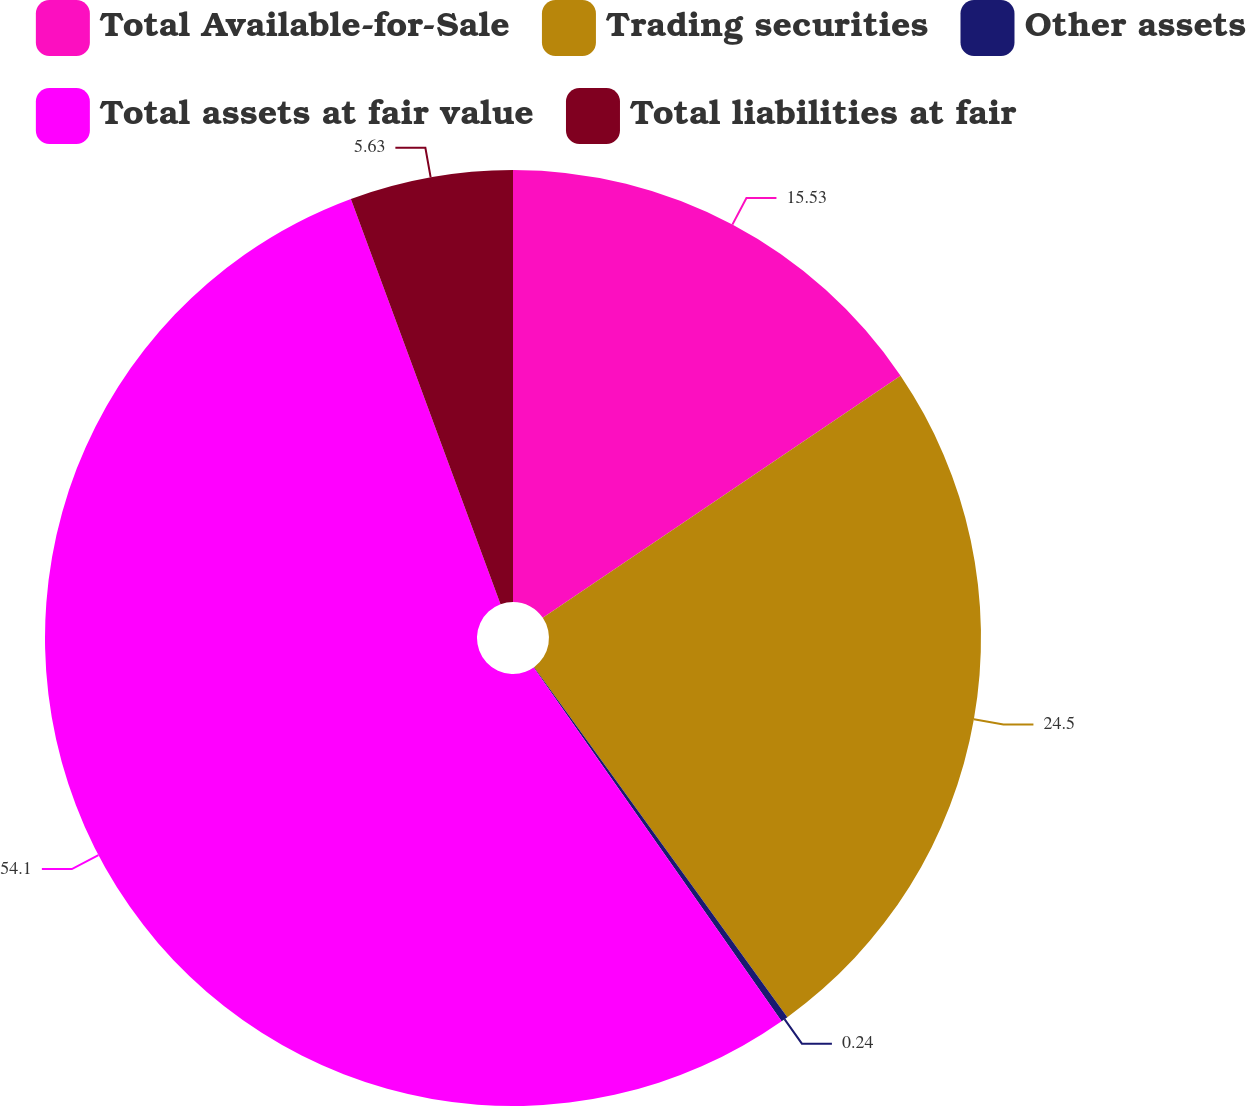Convert chart to OTSL. <chart><loc_0><loc_0><loc_500><loc_500><pie_chart><fcel>Total Available-for-Sale<fcel>Trading securities<fcel>Other assets<fcel>Total assets at fair value<fcel>Total liabilities at fair<nl><fcel>15.53%<fcel>24.5%<fcel>0.24%<fcel>54.1%<fcel>5.63%<nl></chart> 